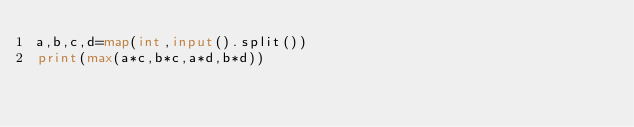Convert code to text. <code><loc_0><loc_0><loc_500><loc_500><_Python_>a,b,c,d=map(int,input().split())
print(max(a*c,b*c,a*d,b*d))</code> 